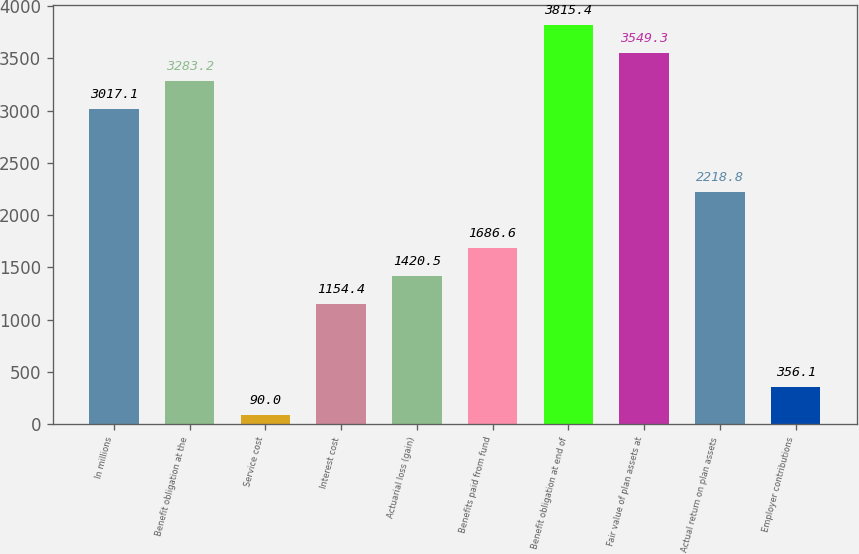Convert chart. <chart><loc_0><loc_0><loc_500><loc_500><bar_chart><fcel>In millions<fcel>Benefit obligation at the<fcel>Service cost<fcel>Interest cost<fcel>Actuarial loss (gain)<fcel>Benefits paid from fund<fcel>Benefit obligation at end of<fcel>Fair value of plan assets at<fcel>Actual return on plan assets<fcel>Employer contributions<nl><fcel>3017.1<fcel>3283.2<fcel>90<fcel>1154.4<fcel>1420.5<fcel>1686.6<fcel>3815.4<fcel>3549.3<fcel>2218.8<fcel>356.1<nl></chart> 